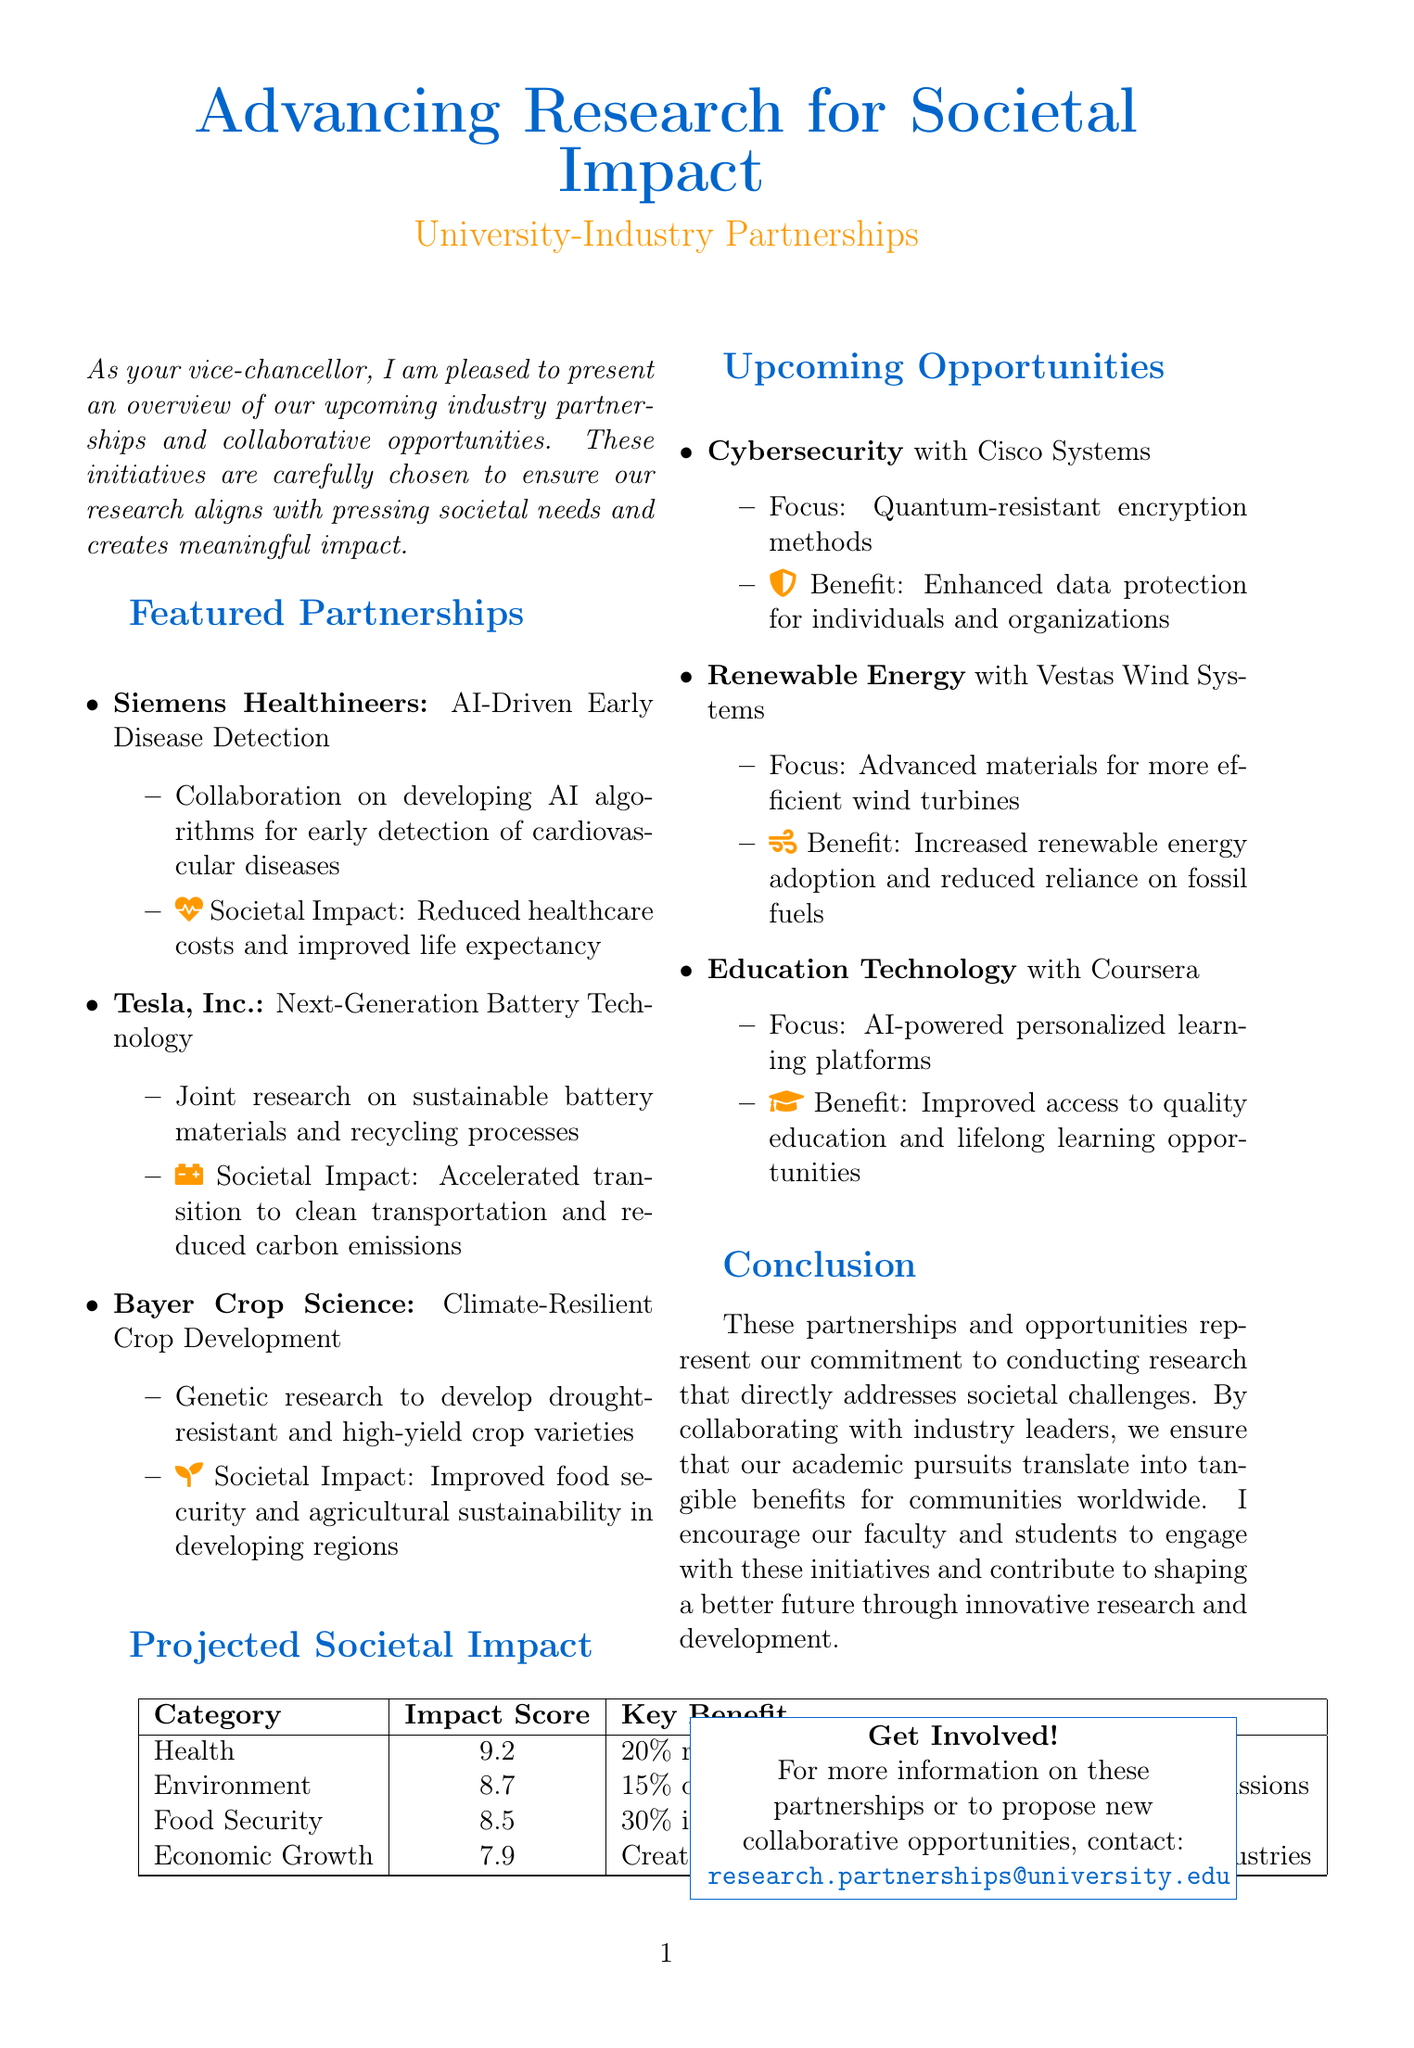What is the title of the newsletter? The title is prominently displayed at the top of the document, which is focused on university-industry partnerships.
Answer: Advancing Research for Societal Impact: University-Industry Partnerships Who is collaborating with Siemens Healthineers? Siemens Healthineers is mentioned in the context of a specific project related to AI and healthcare in the newsletter.
Answer: University What is the impact score for the Environment category? The impact score for the Environment category is provided in a table within the infographic section of the document.
Answer: 8.7 What is the societal benefit of partnering with Cisco Systems? This benefit is detailed in the upcoming opportunities section, focusing on data protection.
Answer: Enhanced data protection for individuals and organizations Which industry sector is involved with the development of advanced materials for efficient wind turbines? The sector is listed alongside its potential partner and research focus in the upcoming opportunities section.
Answer: Renewable Energy What percentage increase in crop yields is projected for drought-prone areas? This statistic is found in the infographic, summarizing the societal impact of food security initiatives.
Answer: 30% How many high-skilled jobs are expected to be created according to the Economic Growth category? The expected job creation number is directly noted in the table that outlines the projected societal impacts of collaborations.
Answer: 5000+ What is the primary focus of the collaboration with Vestas Wind Systems? The focus of this partnership is indicated in the description of the upcoming opportunities section.
Answer: Advanced materials for more efficient wind turbines What is the overall aim of the partnerships mentioned in the newsletter? The introduction and conclusion provide insight into the overarching goal of these partnerships.
Answer: Address societal challenges 